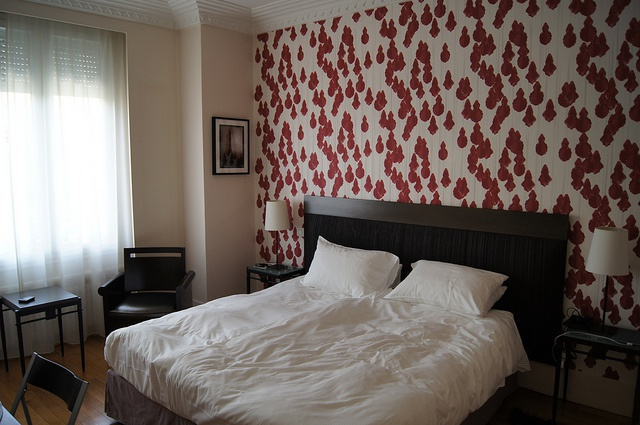Describe the objects in this image and their specific colors. I can see bed in black, darkgray, and gray tones, chair in black and gray tones, and chair in black, maroon, and gray tones in this image. 